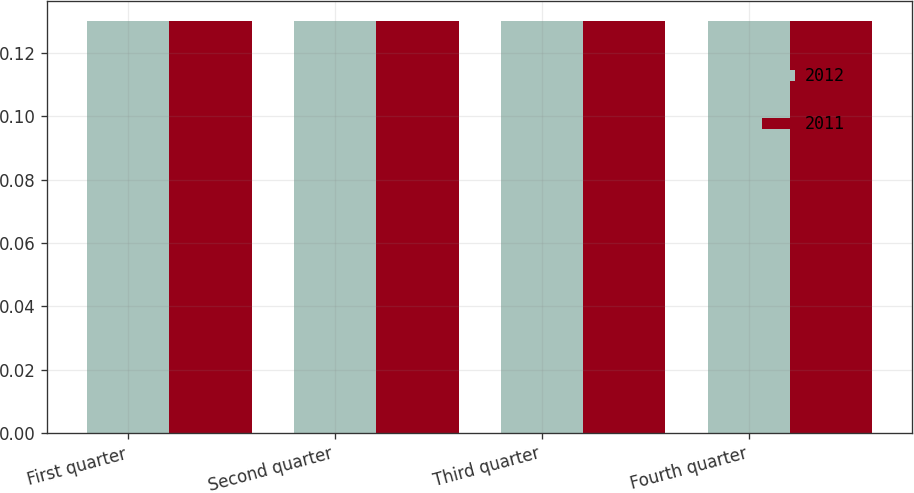Convert chart. <chart><loc_0><loc_0><loc_500><loc_500><stacked_bar_chart><ecel><fcel>First quarter<fcel>Second quarter<fcel>Third quarter<fcel>Fourth quarter<nl><fcel>2012<fcel>0.13<fcel>0.13<fcel>0.13<fcel>0.13<nl><fcel>2011<fcel>0.13<fcel>0.13<fcel>0.13<fcel>0.13<nl></chart> 